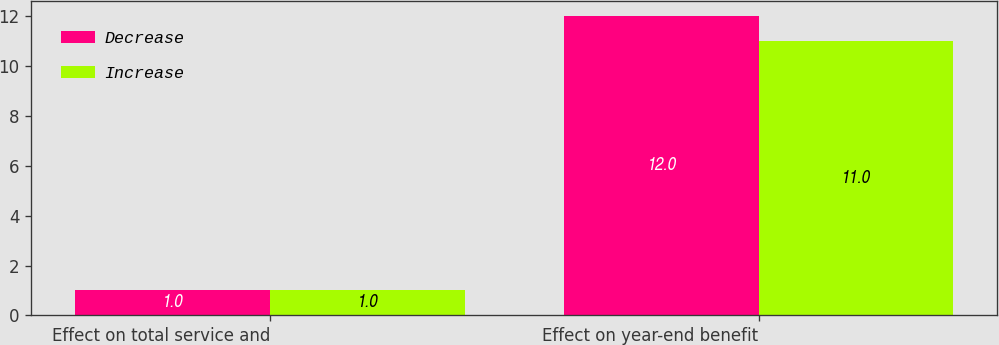Convert chart. <chart><loc_0><loc_0><loc_500><loc_500><stacked_bar_chart><ecel><fcel>Effect on total service and<fcel>Effect on year-end benefit<nl><fcel>Decrease<fcel>1<fcel>12<nl><fcel>Increase<fcel>1<fcel>11<nl></chart> 